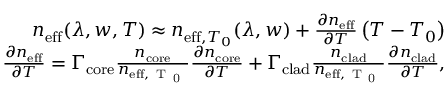<formula> <loc_0><loc_0><loc_500><loc_500>\begin{array} { r } { n _ { e f f } ( \lambda , w , T ) \approx n _ { e f f , T _ { 0 } } ( \lambda , w ) + \frac { \partial n _ { e f f } } { \partial T } \left ( T - T _ { 0 } \right ) } \\ { \frac { \partial n _ { e f f } } { \partial T } = \Gamma _ { c o r e } \frac { n _ { c o r e } } { n _ { e f f , T _ { 0 } } } \frac { \partial n _ { c o r e } } { \partial T } + \Gamma _ { c l a d } \frac { n _ { c l a d } } { n _ { e f f , T _ { 0 } } } \frac { \partial n _ { c l a d } } { \partial T } , } \end{array}</formula> 